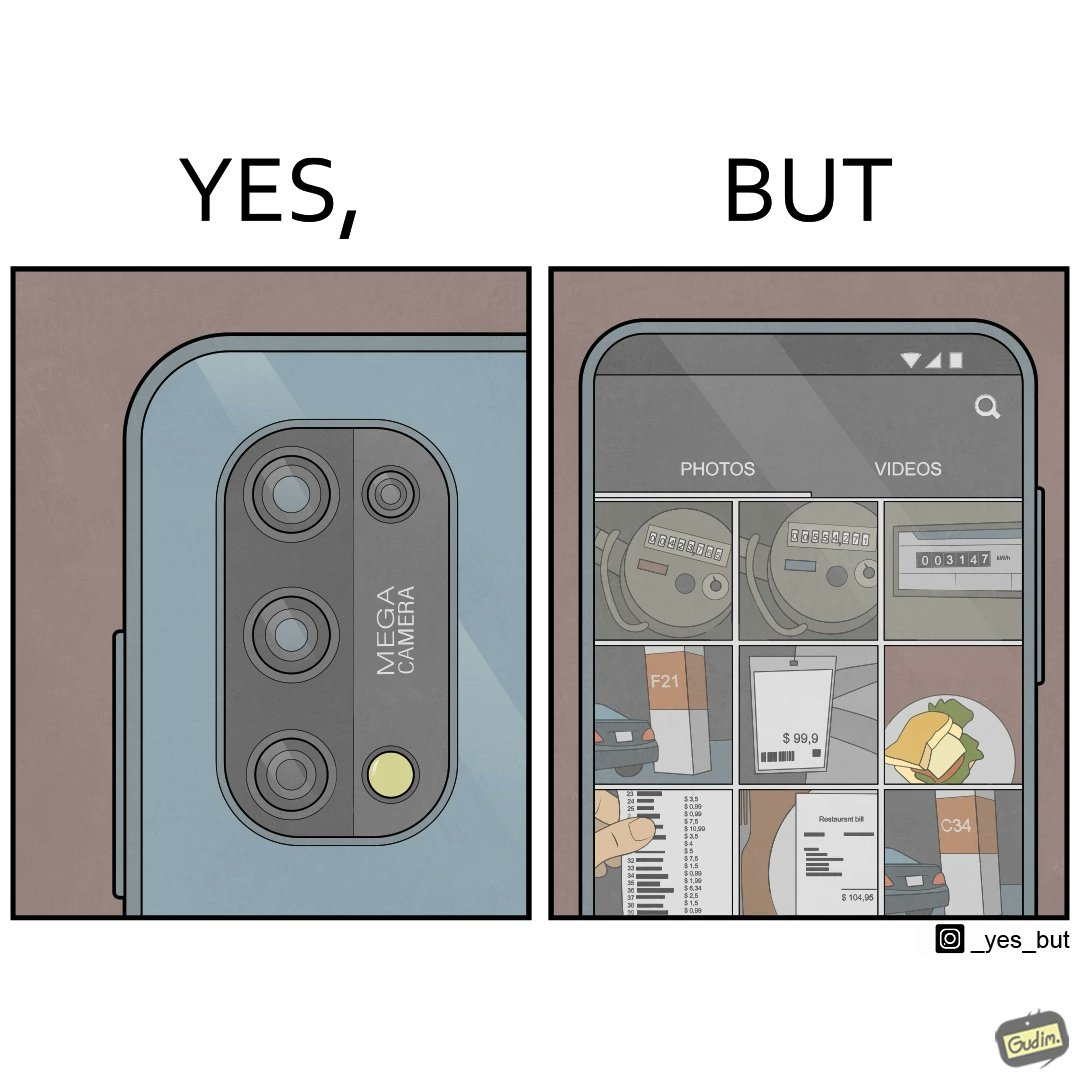Describe the contrast between the left and right parts of this image. In the left part of the image: Image of a phone's camera module. In the right part of the image: camera roll of a person's phone 